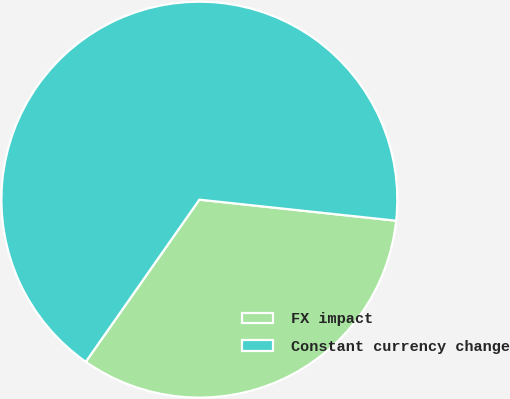Convert chart. <chart><loc_0><loc_0><loc_500><loc_500><pie_chart><fcel>FX impact<fcel>Constant currency change<nl><fcel>33.03%<fcel>66.97%<nl></chart> 